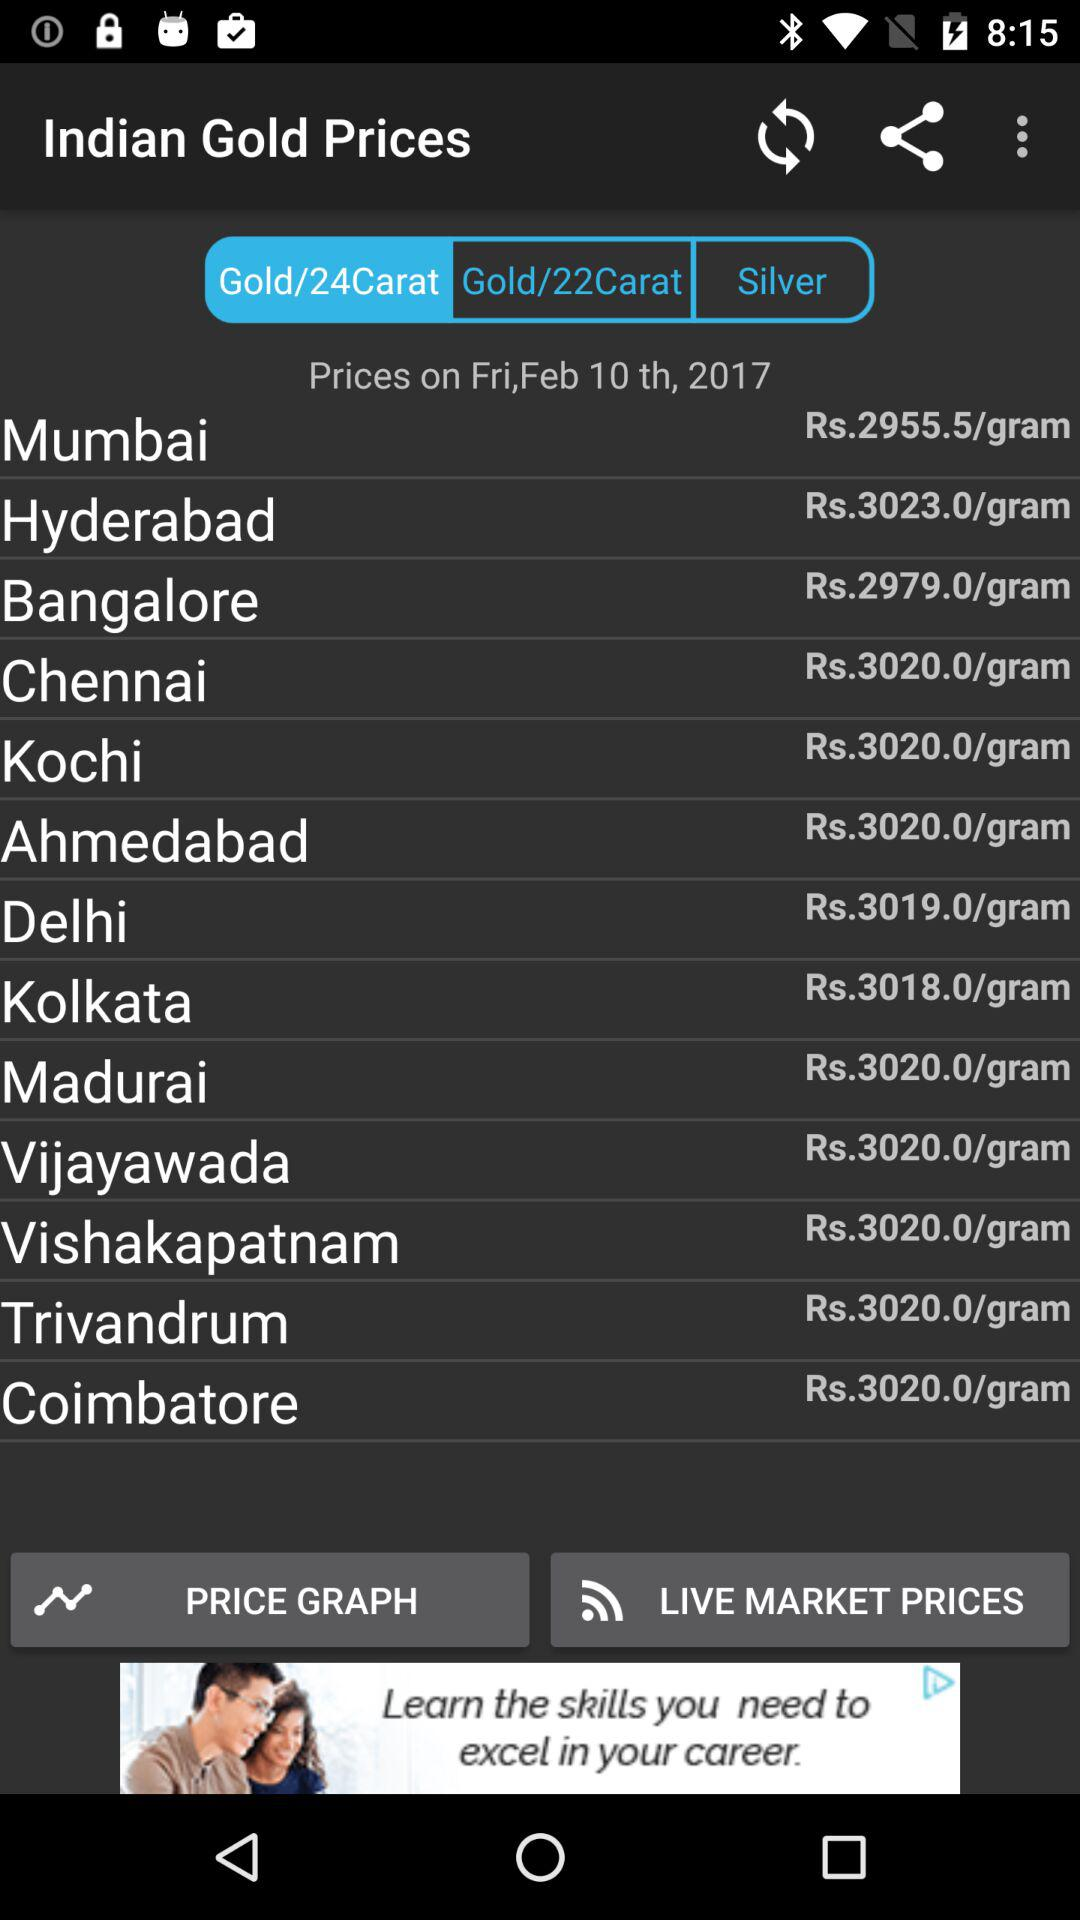What state costs Rs. 3018 per gram for gold? The state is Kolkata. 